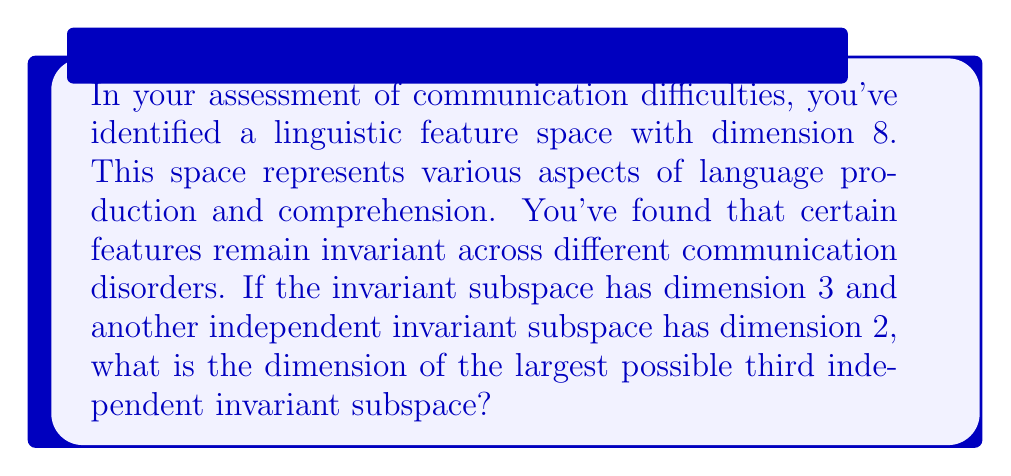Can you answer this question? Let's approach this step-by-step:

1) First, recall that for a vector space $V$ and its subspaces $W_1, W_2, ..., W_k$, if these subspaces are independent, then:

   $$\dim(W_1 + W_2 + ... + W_k) = \dim(W_1) + \dim(W_2) + ... + \dim(W_k)$$

2) We're given that the total dimension of the linguistic feature space is 8:

   $$\dim(V) = 8$$

3) We're also told that there are two independent invariant subspaces with dimensions 3 and 2:

   $$\dim(W_1) = 3, \dim(W_2) = 2$$

4) Let's call the third independent invariant subspace $W_3$. We need to find the maximum possible value of $\dim(W_3)$.

5) Since all three subspaces are independent, their sum must be a subspace of $V$:

   $$W_1 + W_2 + W_3 \subseteq V$$

6) Therefore:

   $$\dim(W_1) + \dim(W_2) + \dim(W_3) \leq \dim(V)$$

7) Substituting the known values:

   $$3 + 2 + \dim(W_3) \leq 8$$

8) Solving for $\dim(W_3)$:

   $$\dim(W_3) \leq 8 - 5 = 3$$

9) Thus, the largest possible dimension for the third independent invariant subspace is 3.
Answer: 3 